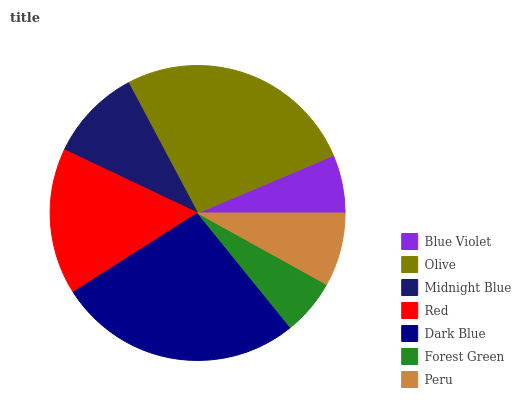Is Forest Green the minimum?
Answer yes or no. Yes. Is Dark Blue the maximum?
Answer yes or no. Yes. Is Olive the minimum?
Answer yes or no. No. Is Olive the maximum?
Answer yes or no. No. Is Olive greater than Blue Violet?
Answer yes or no. Yes. Is Blue Violet less than Olive?
Answer yes or no. Yes. Is Blue Violet greater than Olive?
Answer yes or no. No. Is Olive less than Blue Violet?
Answer yes or no. No. Is Midnight Blue the high median?
Answer yes or no. Yes. Is Midnight Blue the low median?
Answer yes or no. Yes. Is Red the high median?
Answer yes or no. No. Is Blue Violet the low median?
Answer yes or no. No. 